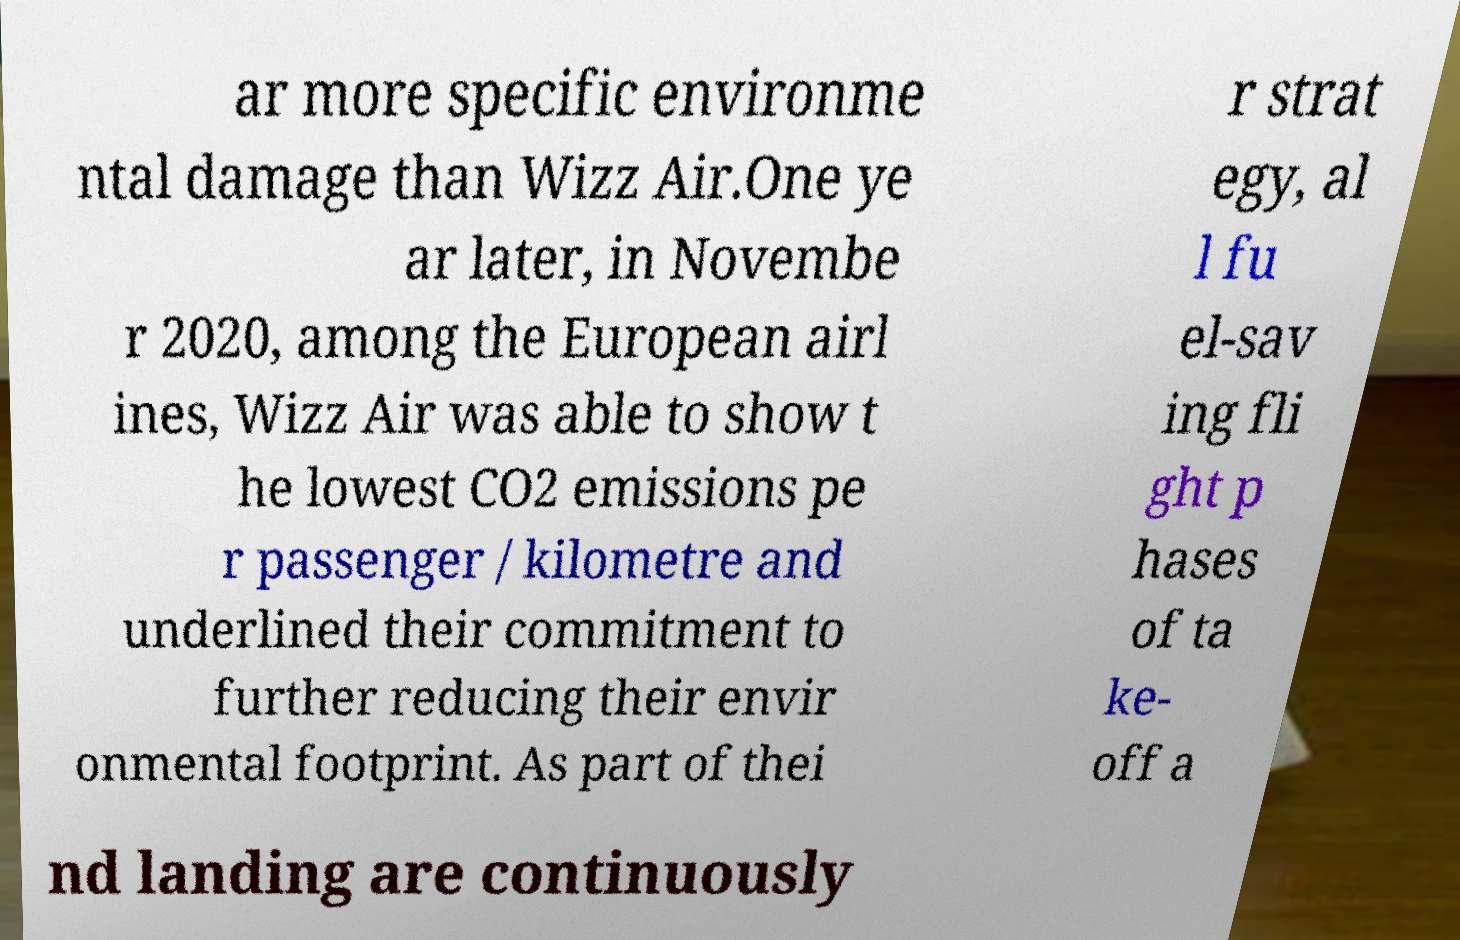Can you accurately transcribe the text from the provided image for me? ar more specific environme ntal damage than Wizz Air.One ye ar later, in Novembe r 2020, among the European airl ines, Wizz Air was able to show t he lowest CO2 emissions pe r passenger / kilometre and underlined their commitment to further reducing their envir onmental footprint. As part of thei r strat egy, al l fu el-sav ing fli ght p hases of ta ke- off a nd landing are continuously 